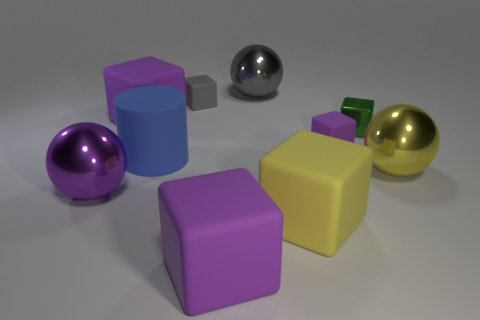What number of other metal objects are the same shape as the green thing?
Your answer should be very brief. 0. What color is the large rubber block that is behind the large metal thing that is to the left of the gray matte thing?
Give a very brief answer. Purple. Do the gray matte thing and the big purple matte object to the left of the large cylinder have the same shape?
Provide a succinct answer. Yes. There is a purple thing that is in front of the metallic thing that is on the left side of the big purple matte object that is behind the blue rubber cylinder; what is its material?
Offer a very short reply. Rubber. Are there any green shiny things of the same size as the purple sphere?
Your answer should be very brief. No. What size is the purple sphere that is made of the same material as the green thing?
Keep it short and to the point. Large. There is a green object; what shape is it?
Offer a very short reply. Cube. Is the large blue object made of the same material as the ball behind the metal block?
Offer a very short reply. No. What number of things are either big blocks or large things?
Ensure brevity in your answer.  7. Are there any big blue matte objects?
Give a very brief answer. Yes. 